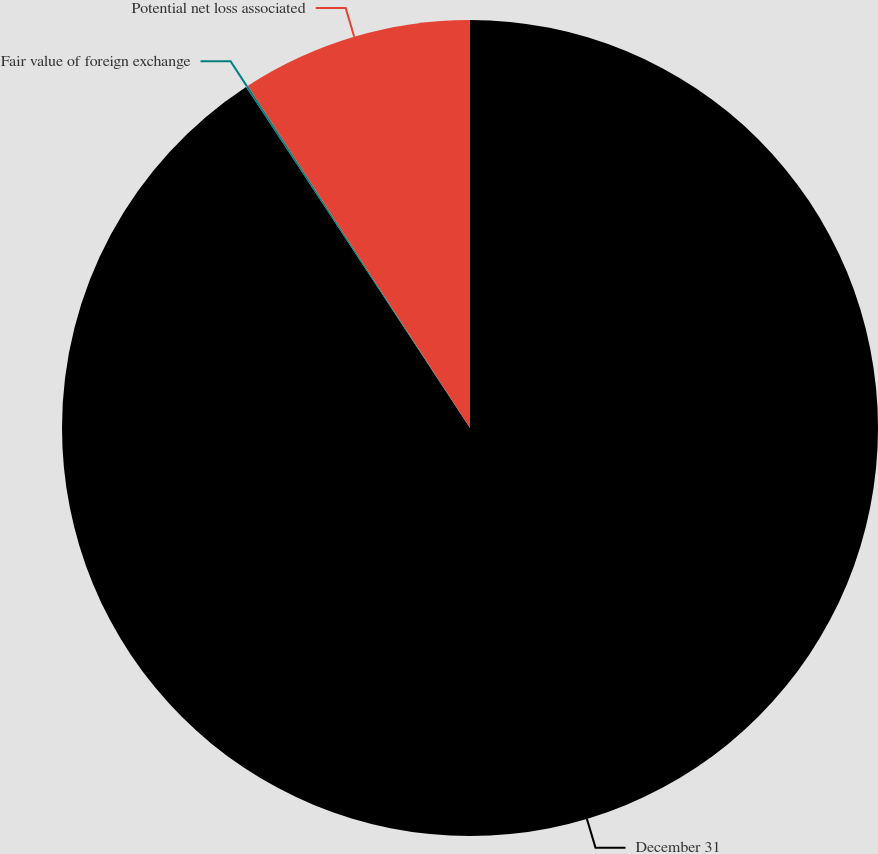<chart> <loc_0><loc_0><loc_500><loc_500><pie_chart><fcel>December 31<fcel>Fair value of foreign exchange<fcel>Potential net loss associated<nl><fcel>90.75%<fcel>0.09%<fcel>9.16%<nl></chart> 